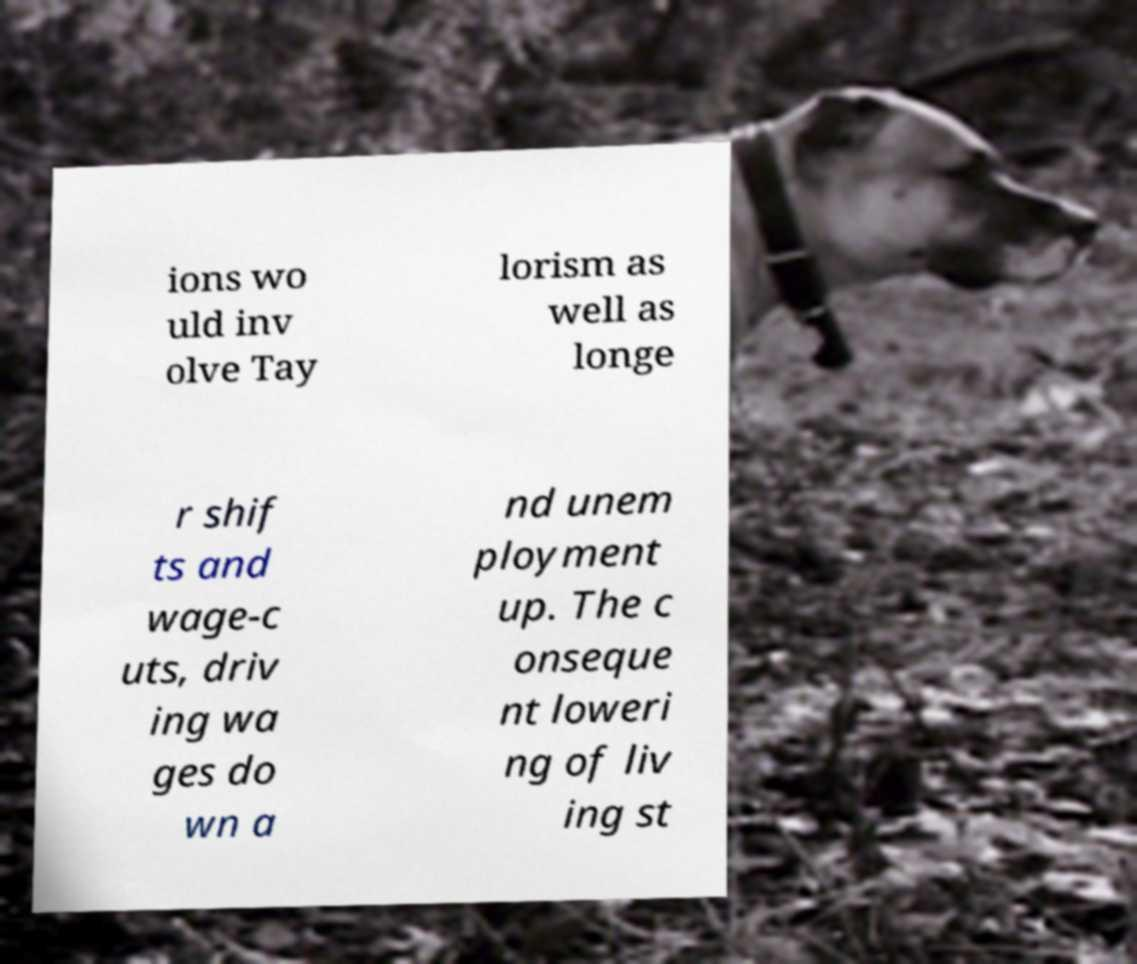Could you extract and type out the text from this image? ions wo uld inv olve Tay lorism as well as longe r shif ts and wage-c uts, driv ing wa ges do wn a nd unem ployment up. The c onseque nt loweri ng of liv ing st 